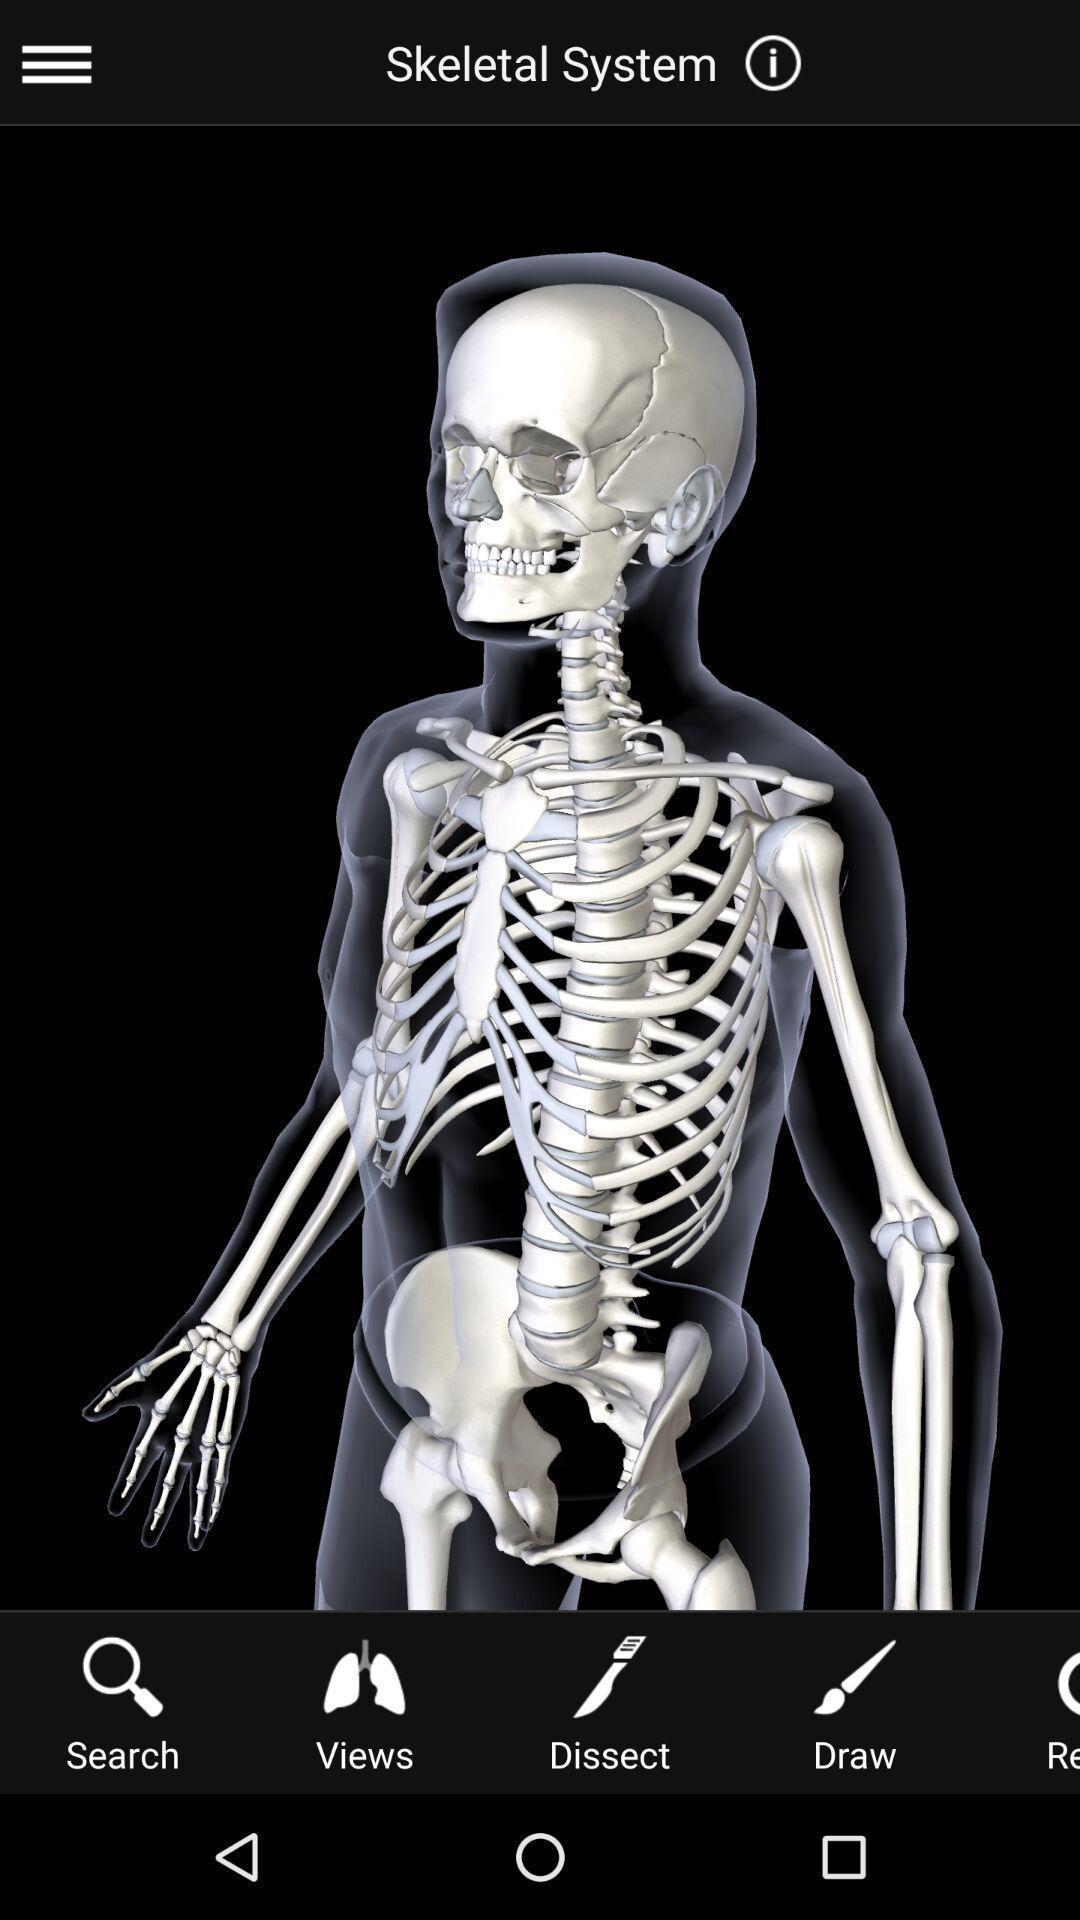Describe this image in words. Skeleton image of a virtual app. 